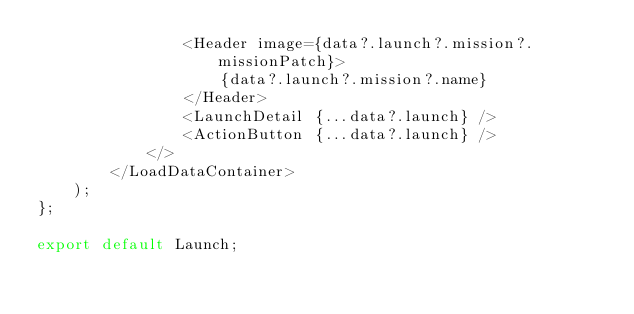Convert code to text. <code><loc_0><loc_0><loc_500><loc_500><_TypeScript_>                <Header image={data?.launch?.mission?.missionPatch}>
                    {data?.launch?.mission?.name}
                </Header>
                <LaunchDetail {...data?.launch} />
                <ActionButton {...data?.launch} />
            </>
        </LoadDataContainer>
    );
};

export default Launch;
</code> 